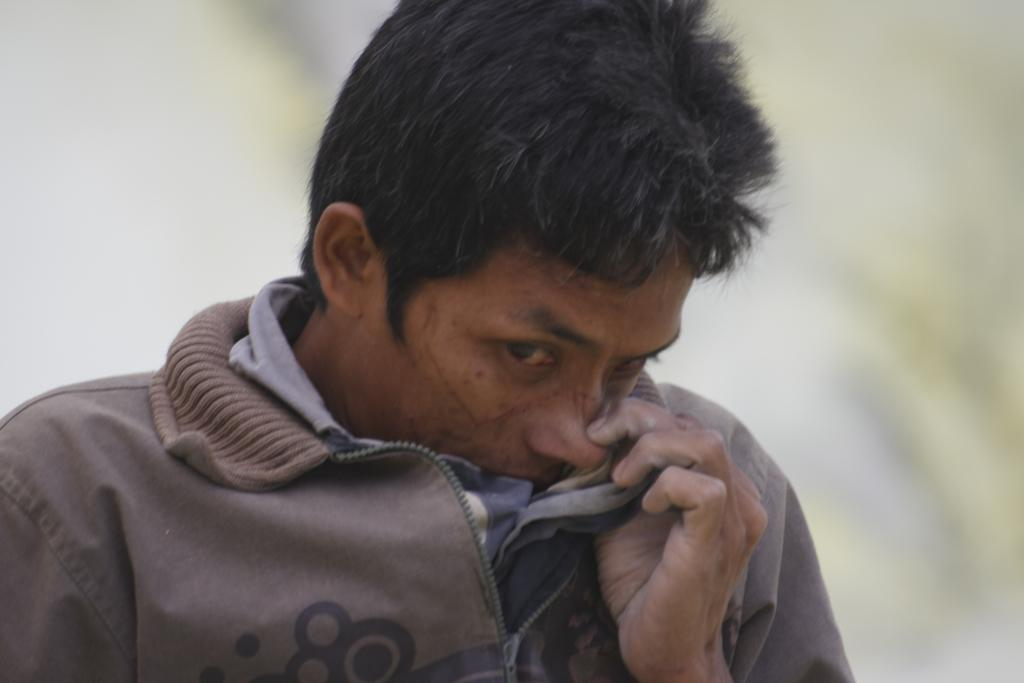What is the main subject of the image? There is a man in the center of the image. Can you describe the background of the image? The background of the image is not clear. What type of watch is the man wearing in the image? There is no watch visible on the man in the image. What type of linen is draped over the man's shoulders in the image? There is no linen present in the image. What mode of transport is the man using in the image? There is no mode of transport visible in the image. 